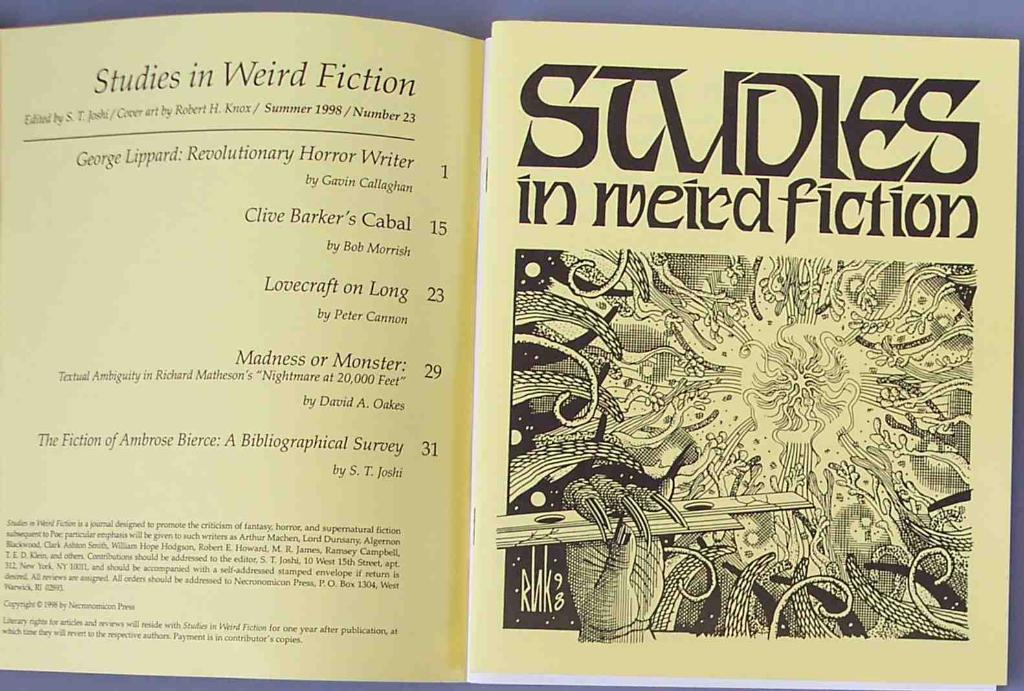<image>
Provide a brief description of the given image. A book called Studies in Weird Fiction with cover art by Robert H. Knox. 